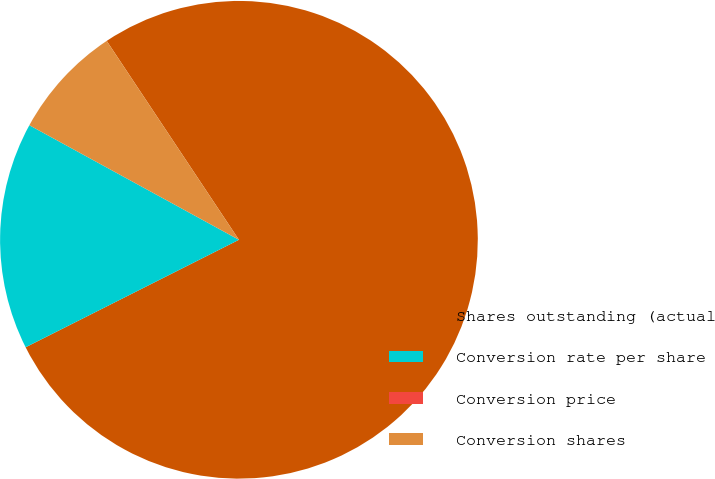Convert chart. <chart><loc_0><loc_0><loc_500><loc_500><pie_chart><fcel>Shares outstanding (actual<fcel>Conversion rate per share<fcel>Conversion price<fcel>Conversion shares<nl><fcel>76.91%<fcel>15.39%<fcel>0.0%<fcel>7.7%<nl></chart> 